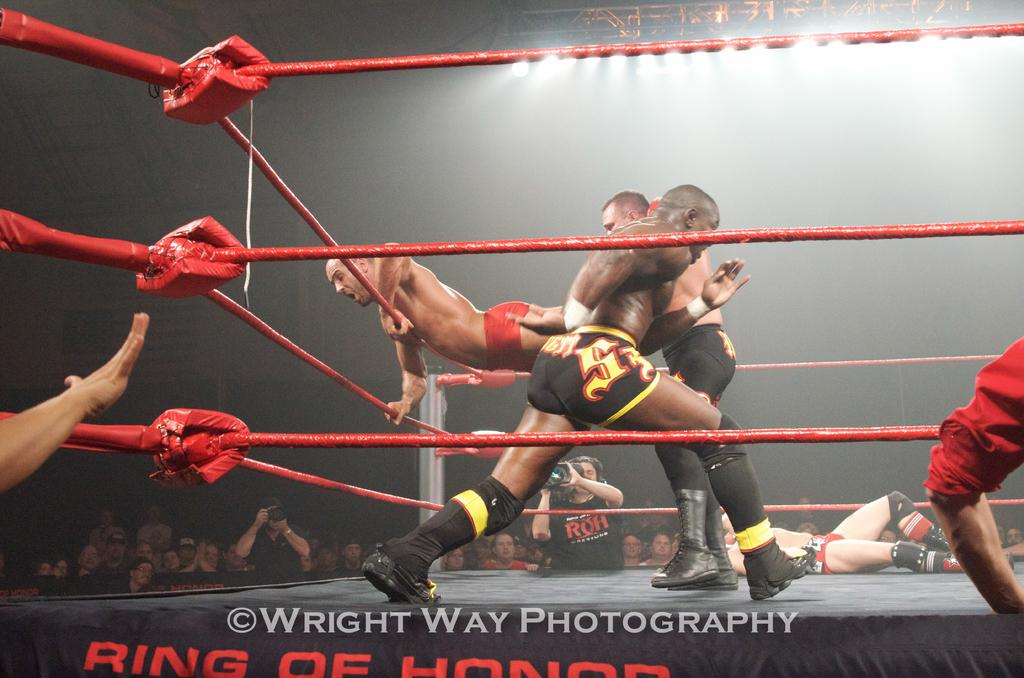<image>
Present a compact description of the photo's key features. Four men fight in the Ring of Honor, one bouncing up on the ropes. 